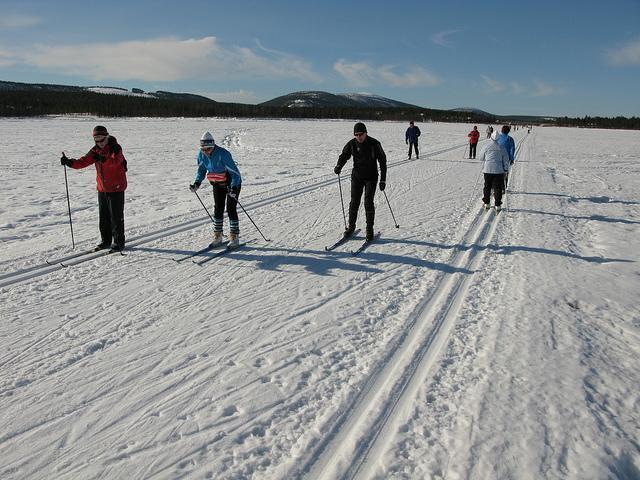What is the location of the sun in the image?
Choose the correct response and explain in the format: 'Answer: answer
Rationale: rationale.'
Options: Right, front, back, left. Answer: left.
Rationale: Based on the orientation of the shadows and the people creating them, the location of the sun is discernible. 